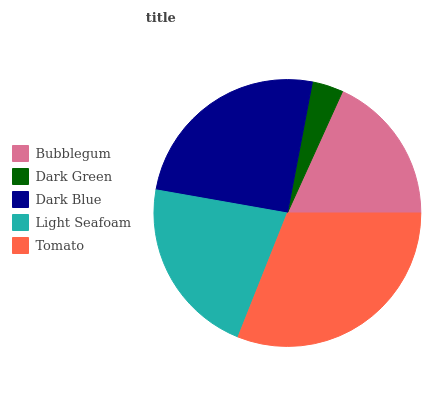Is Dark Green the minimum?
Answer yes or no. Yes. Is Tomato the maximum?
Answer yes or no. Yes. Is Dark Blue the minimum?
Answer yes or no. No. Is Dark Blue the maximum?
Answer yes or no. No. Is Dark Blue greater than Dark Green?
Answer yes or no. Yes. Is Dark Green less than Dark Blue?
Answer yes or no. Yes. Is Dark Green greater than Dark Blue?
Answer yes or no. No. Is Dark Blue less than Dark Green?
Answer yes or no. No. Is Light Seafoam the high median?
Answer yes or no. Yes. Is Light Seafoam the low median?
Answer yes or no. Yes. Is Tomato the high median?
Answer yes or no. No. Is Dark Green the low median?
Answer yes or no. No. 